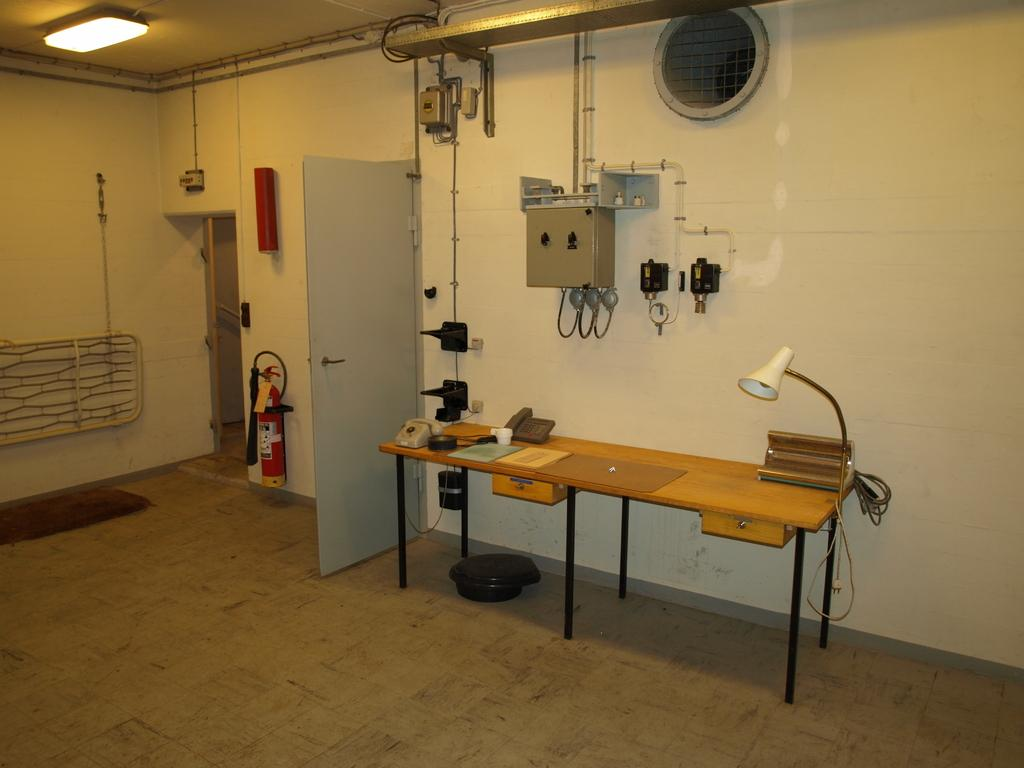What objects can be seen on the table in the image? There are telephones on the table in the image. What is one architectural feature visible in the image? There is a door visible in the image. What type of infrastructure is present in the image? Pipes are present in the image. What safety device is visible in the image? A fire extinguisher is visible in the image. What can be seen attached to the white wall in the image? There are objects attached to a white wall in the image. What type of music can be heard coming from the sheet in the image? There is no sheet or music present in the image. 